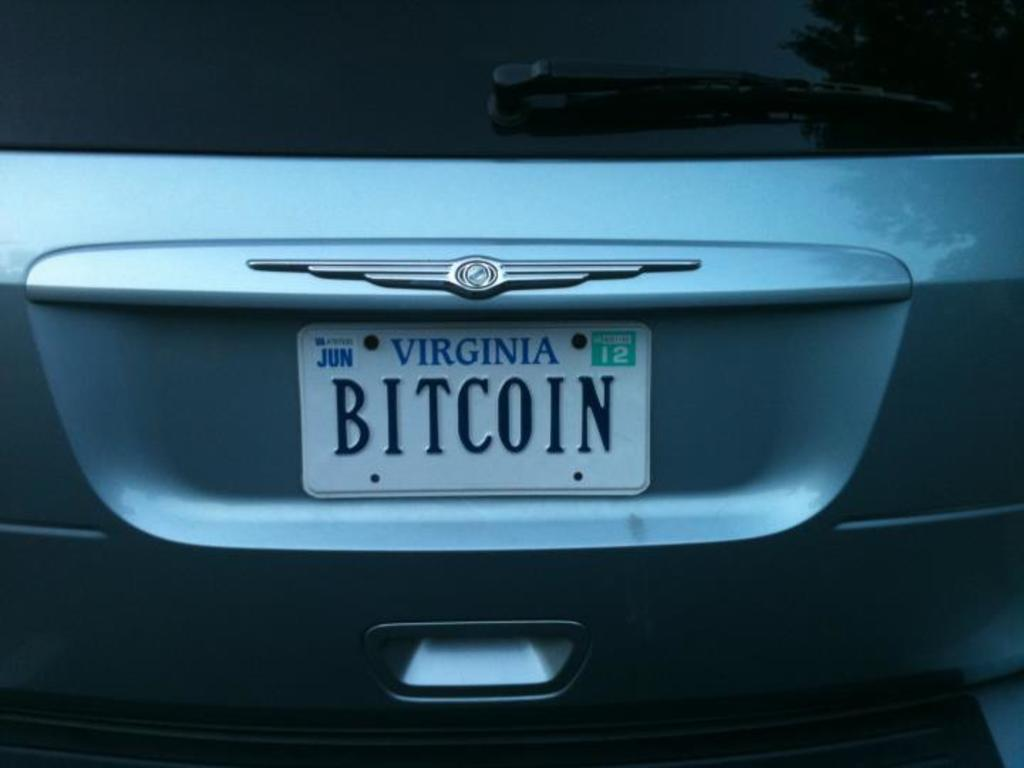What is the main subject of the image? The main subject of the image is a car. Can you describe any specific details about the car? The image is a zoomed-in picture of the car, so we can see the number plate. What is the relationship between the car and the person's brother in the image? There is no person or brother mentioned in the image; it only features a car with a visible number plate. 